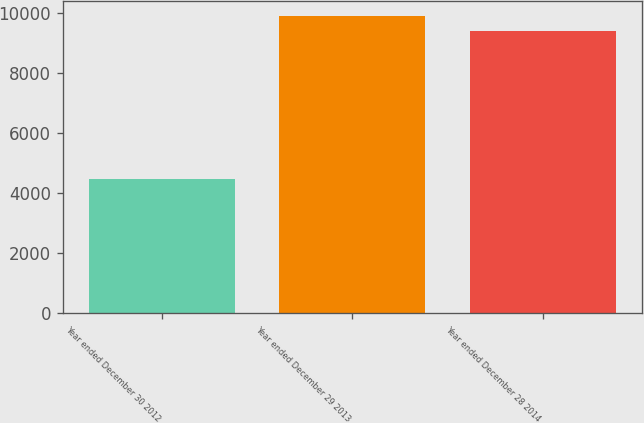Convert chart. <chart><loc_0><loc_0><loc_500><loc_500><bar_chart><fcel>Year ended December 30 2012<fcel>Year ended December 29 2013<fcel>Year ended December 28 2014<nl><fcel>4456<fcel>9897.1<fcel>9400<nl></chart> 